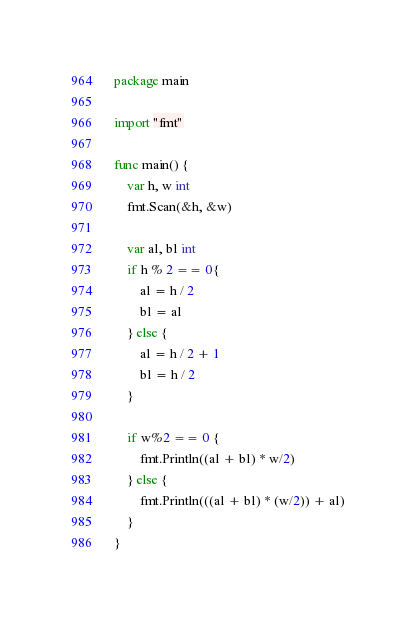Convert code to text. <code><loc_0><loc_0><loc_500><loc_500><_Go_>package main

import "fmt"

func main() {
	var h, w int
	fmt.Scan(&h, &w)

	var al, bl int
	if h % 2 == 0{
		al = h / 2
		bl = al
	} else {
		al = h / 2 + 1
		bl = h / 2
	}

	if w%2 == 0 {
		fmt.Println((al + bl) * w/2)
	} else {
		fmt.Println(((al + bl) * (w/2)) + al)
	}
}</code> 